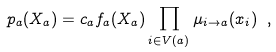<formula> <loc_0><loc_0><loc_500><loc_500>p _ { a } ( X _ { a } ) = c _ { a } f _ { a } ( X _ { a } ) \prod _ { i \in V ( a ) } \mu _ { i \to a } ( x _ { i } ) \ ,</formula> 